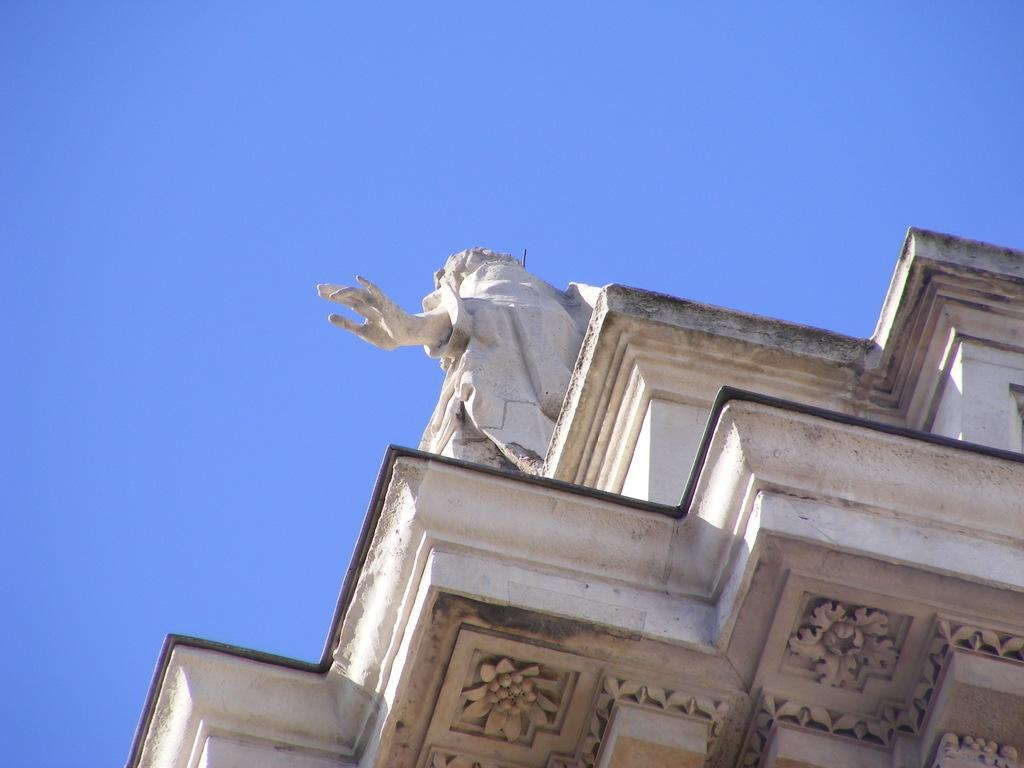What is the main subject of the image? There is a part of a building in the image. What features can be seen on the building? The building has sculptures. What can be seen in the background of the image? The sky is visible in the background of the image. Can you tell me how many dogs are depicted in the sculptures on the building? There is no information about dogs or any specific sculptures on the building in the provided facts, so it cannot be determined from the image. 